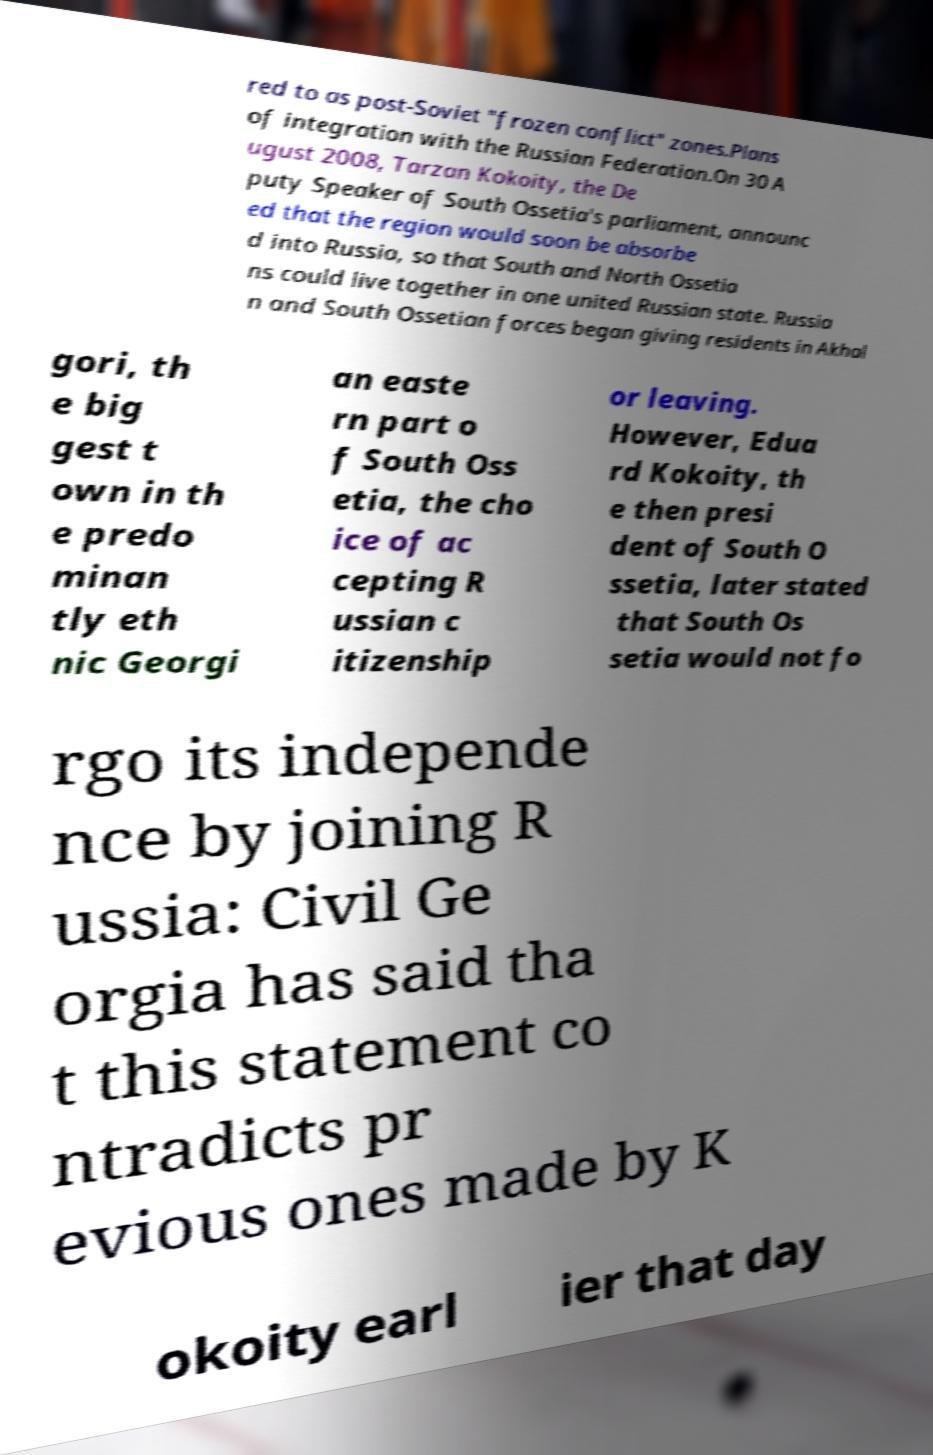Could you extract and type out the text from this image? red to as post-Soviet "frozen conflict" zones.Plans of integration with the Russian Federation.On 30 A ugust 2008, Tarzan Kokoity, the De puty Speaker of South Ossetia's parliament, announc ed that the region would soon be absorbe d into Russia, so that South and North Ossetia ns could live together in one united Russian state. Russia n and South Ossetian forces began giving residents in Akhal gori, th e big gest t own in th e predo minan tly eth nic Georgi an easte rn part o f South Oss etia, the cho ice of ac cepting R ussian c itizenship or leaving. However, Edua rd Kokoity, th e then presi dent of South O ssetia, later stated that South Os setia would not fo rgo its independe nce by joining R ussia: Civil Ge orgia has said tha t this statement co ntradicts pr evious ones made by K okoity earl ier that day 